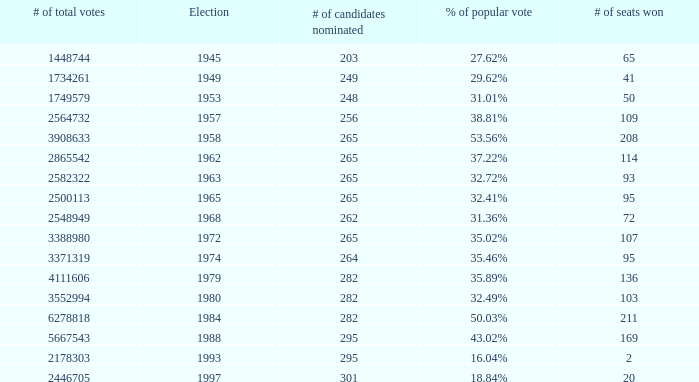What is the election year when the # of candidates nominated was 262? 1.0. 